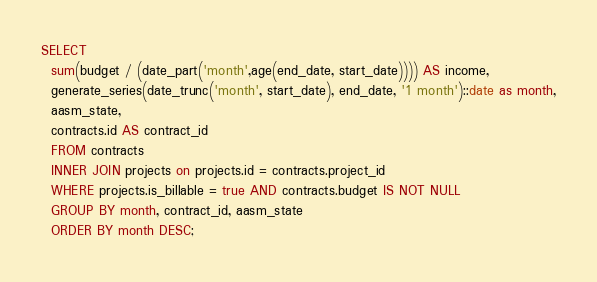<code> <loc_0><loc_0><loc_500><loc_500><_SQL_>SELECT
  sum(budget / (date_part('month',age(end_date, start_date)))) AS income,
  generate_series(date_trunc('month', start_date), end_date, '1 month')::date as month,
  aasm_state,
  contracts.id AS contract_id
  FROM contracts
  INNER JOIN projects on projects.id = contracts.project_id
  WHERE projects.is_billable = true AND contracts.budget IS NOT NULL
  GROUP BY month, contract_id, aasm_state
  ORDER BY month DESC;

</code> 